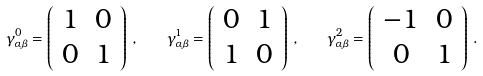Convert formula to latex. <formula><loc_0><loc_0><loc_500><loc_500>\gamma _ { \alpha \beta } ^ { 0 } = \left ( \begin{array} { c c } { 1 } & { 0 } \\ { 0 } & { 1 } \end{array} \right ) \, , \quad \gamma _ { \alpha \beta } ^ { 1 } = \left ( \begin{array} { c c } { 0 } & { 1 } \\ { 1 } & { 0 } \end{array} \right ) \, , \quad \gamma _ { \alpha \beta } ^ { 2 } = \left ( \begin{array} { c c } { - 1 } & { 0 } \\ { 0 } & { 1 } \end{array} \right ) \, .</formula> 